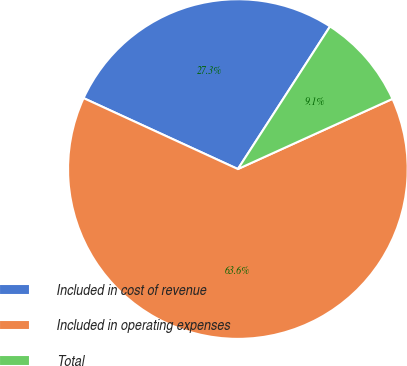<chart> <loc_0><loc_0><loc_500><loc_500><pie_chart><fcel>Included in cost of revenue<fcel>Included in operating expenses<fcel>Total<nl><fcel>27.27%<fcel>63.64%<fcel>9.09%<nl></chart> 